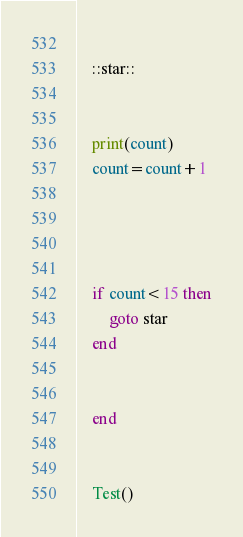Convert code to text. <code><loc_0><loc_0><loc_500><loc_500><_Lua_>    
    ::star::  
    
    
    print(count)
    count=count+1
    
    
        
    
    if count<15 then
        goto star
    end
    
        
    end
    
    
    Test()</code> 